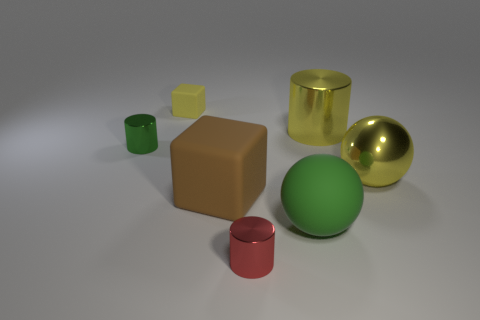Add 2 yellow metal things. How many objects exist? 9 Subtract all cylinders. How many objects are left? 4 Add 3 yellow shiny cylinders. How many yellow shiny cylinders are left? 4 Add 6 tiny yellow things. How many tiny yellow things exist? 7 Subtract 0 cyan balls. How many objects are left? 7 Subtract all tiny green metal things. Subtract all yellow matte cubes. How many objects are left? 5 